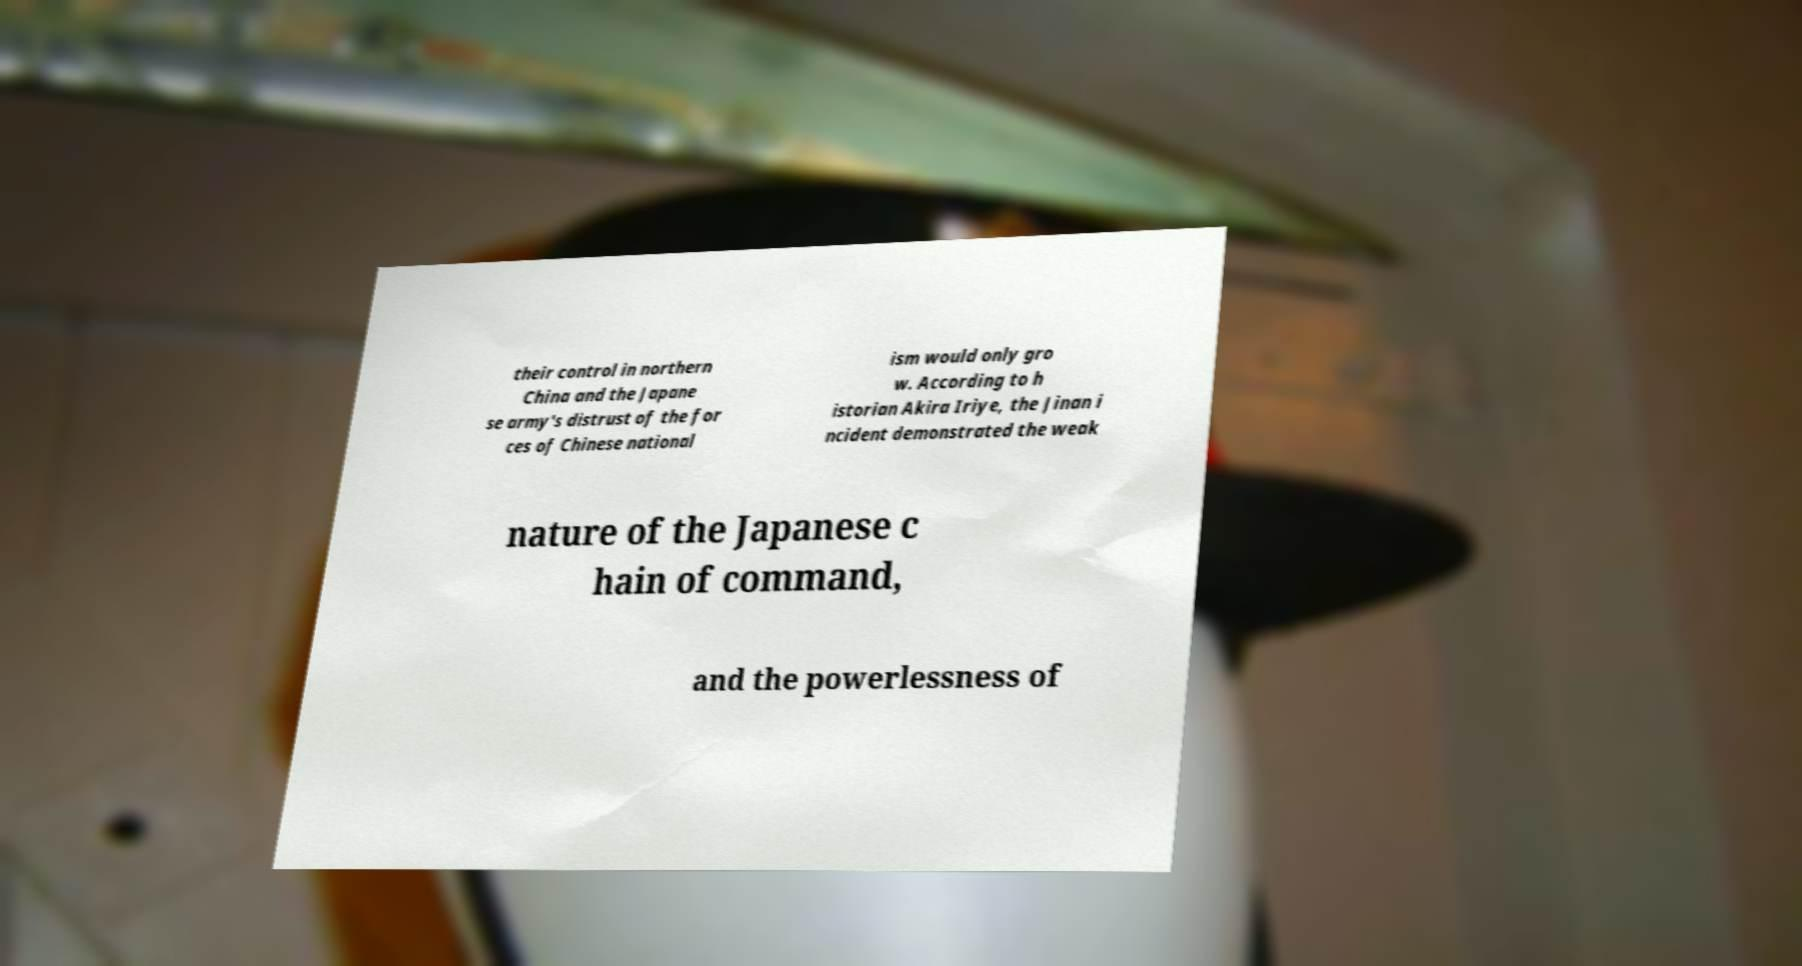Could you extract and type out the text from this image? their control in northern China and the Japane se army's distrust of the for ces of Chinese national ism would only gro w. According to h istorian Akira Iriye, the Jinan i ncident demonstrated the weak nature of the Japanese c hain of command, and the powerlessness of 